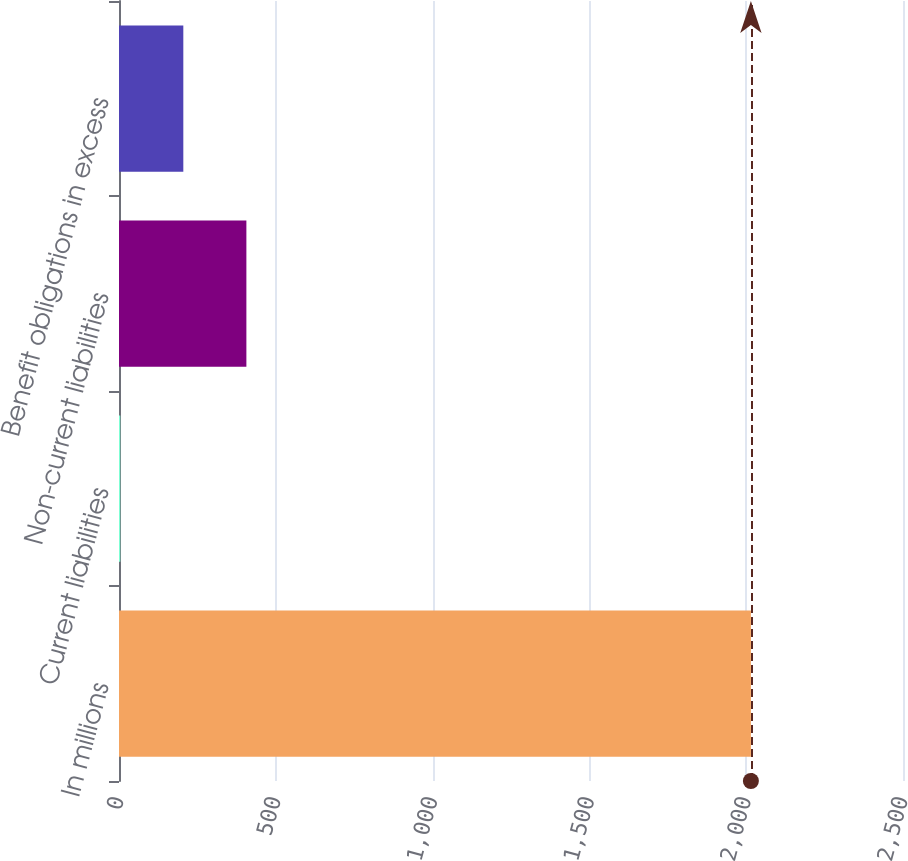Convert chart to OTSL. <chart><loc_0><loc_0><loc_500><loc_500><bar_chart><fcel>In millions<fcel>Current liabilities<fcel>Non-current liabilities<fcel>Benefit obligations in excess<nl><fcel>2015<fcel>4<fcel>406.2<fcel>205.1<nl></chart> 